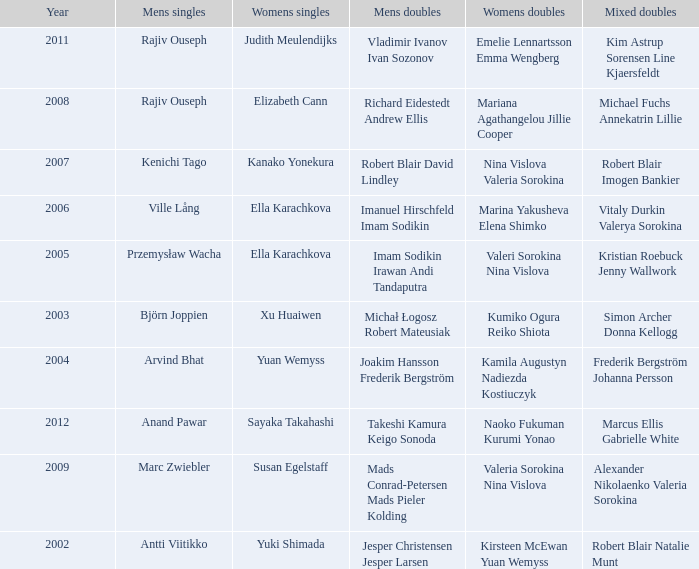What is the womens singles of marcus ellis gabrielle white? Sayaka Takahashi. 